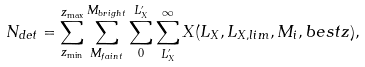<formula> <loc_0><loc_0><loc_500><loc_500>N _ { d e t } = { \sum ^ { z _ { \max } } _ { z _ { \min } } \sum ^ { M _ { b r i g h t } } _ { M _ { f a i n t } } \sum ^ { L _ { X } ^ { \prime } } _ { 0 } \sum ^ { \infty } _ { L _ { X } ^ { \prime } } X ( L _ { X } , L _ { X , l i m } , M _ { i } , b e s t z ) } ,</formula> 